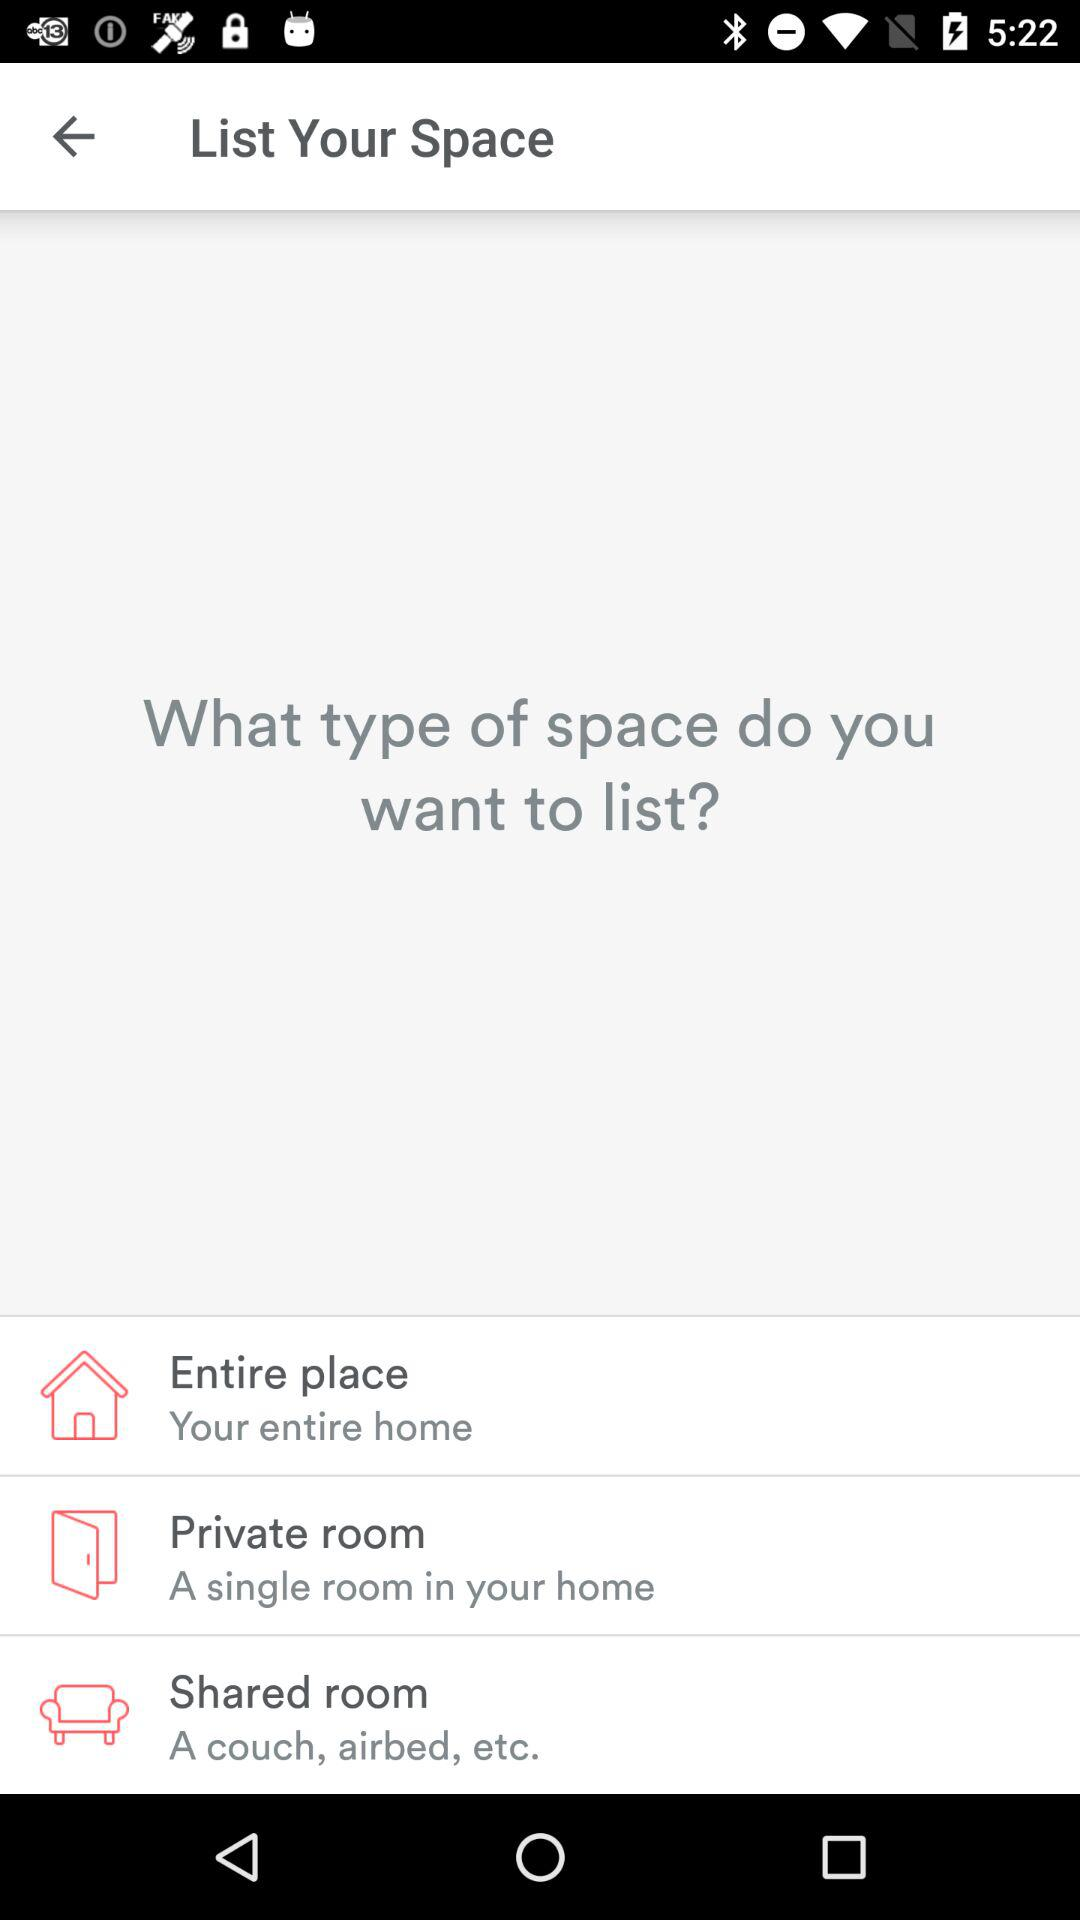Which types of spaces are given for listing? The types of spaces given for listing are "Entire place", "Private room" and "Shared room". 